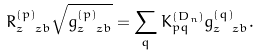Convert formula to latex. <formula><loc_0><loc_0><loc_500><loc_500>R _ { z \, \ z b } ^ { ( p ) } \sqrt { g _ { z \, \ z b } ^ { ( p ) } } = \sum _ { q } K ^ { ( D _ { n } ) } _ { p q } g _ { z \, \ z b } ^ { ( q ) } .</formula> 